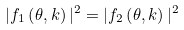Convert formula to latex. <formula><loc_0><loc_0><loc_500><loc_500>| f _ { 1 } \left ( \theta , k \right ) | ^ { 2 } = | f _ { 2 } \left ( \theta , k \right ) | ^ { 2 }</formula> 